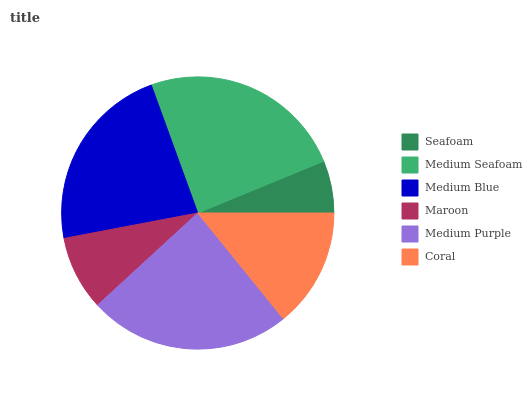Is Seafoam the minimum?
Answer yes or no. Yes. Is Medium Seafoam the maximum?
Answer yes or no. Yes. Is Medium Blue the minimum?
Answer yes or no. No. Is Medium Blue the maximum?
Answer yes or no. No. Is Medium Seafoam greater than Medium Blue?
Answer yes or no. Yes. Is Medium Blue less than Medium Seafoam?
Answer yes or no. Yes. Is Medium Blue greater than Medium Seafoam?
Answer yes or no. No. Is Medium Seafoam less than Medium Blue?
Answer yes or no. No. Is Medium Blue the high median?
Answer yes or no. Yes. Is Coral the low median?
Answer yes or no. Yes. Is Seafoam the high median?
Answer yes or no. No. Is Maroon the low median?
Answer yes or no. No. 